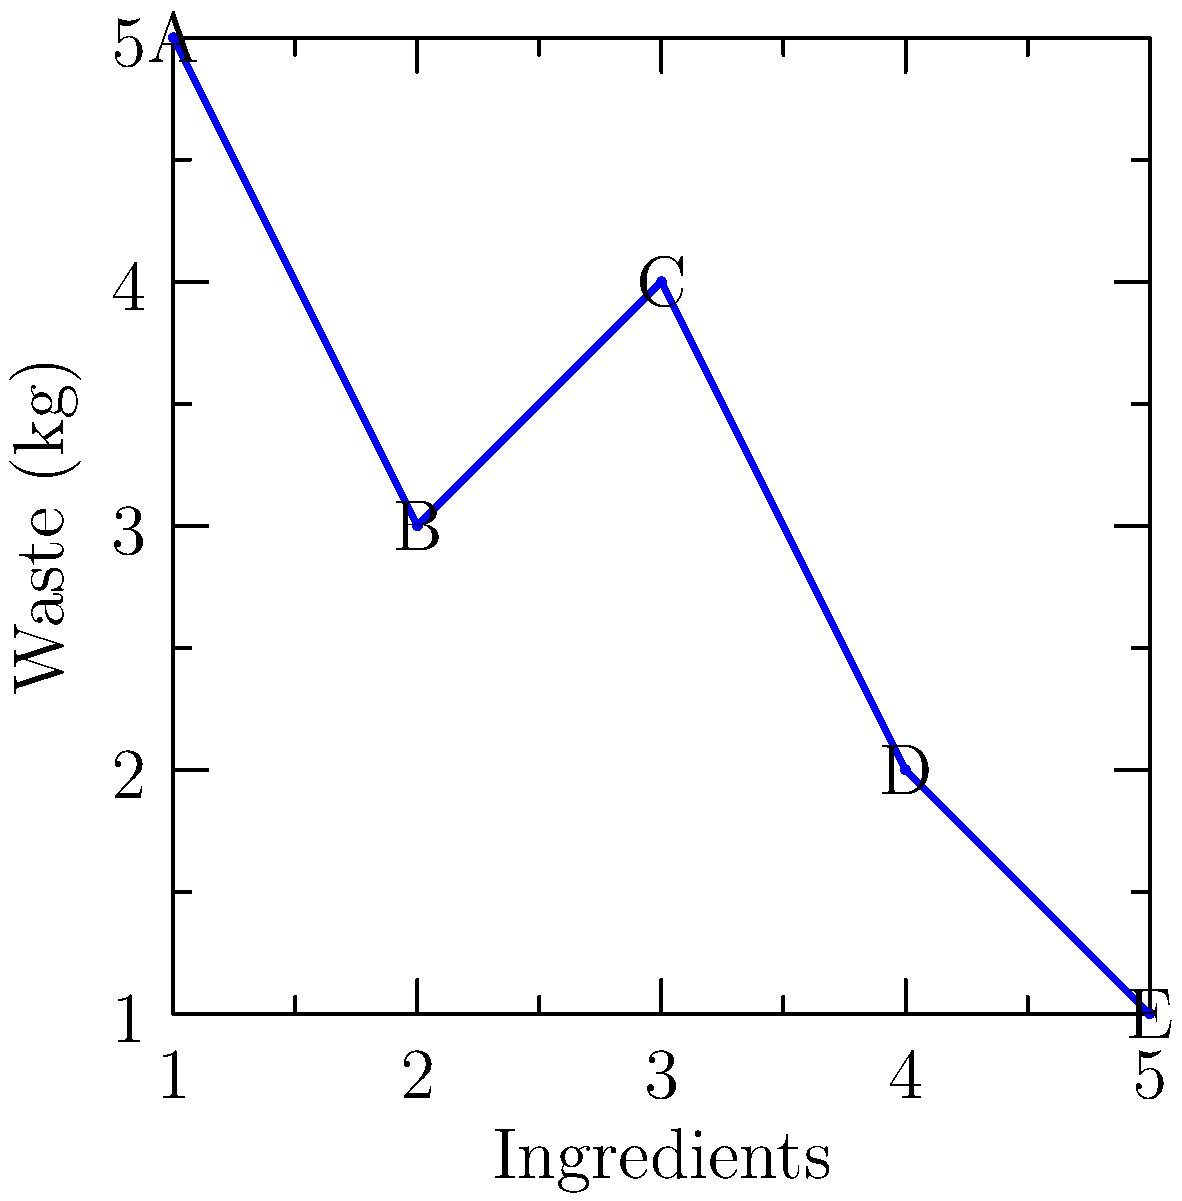As a chef committed to minimizing waste, you're analyzing the waste produced by different ingredient combinations in a recipe. The graph shows the waste produced by 5 ingredients (A, B, C, D, E) in their current order. If you were to apply all possible permutations of these ingredients, how many unique waste patterns could you create? (Assume that changing the order of ingredients affects the waste produced.) To solve this problem, we need to use concepts from permutation groups in group theory. Here's a step-by-step explanation:

1) We have 5 distinct ingredients, so we're dealing with permutations of 5 elements.

2) The number of permutations of n distinct elements is given by n!, where n is the number of elements.

3) In this case, n = 5, so we need to calculate 5!.

4) 5! = 5 × 4 × 3 × 2 × 1 = 120

5) Each permutation will create a unique waste pattern because:
   - The order of ingredients affects the waste produced
   - Each ingredient has a different waste value
   - There are no repeated waste values in the given data

6) Therefore, the number of unique waste patterns is equal to the number of permutations.

Thus, applying all possible permutations of the 5 ingredients will result in 120 unique waste patterns.
Answer: 120 